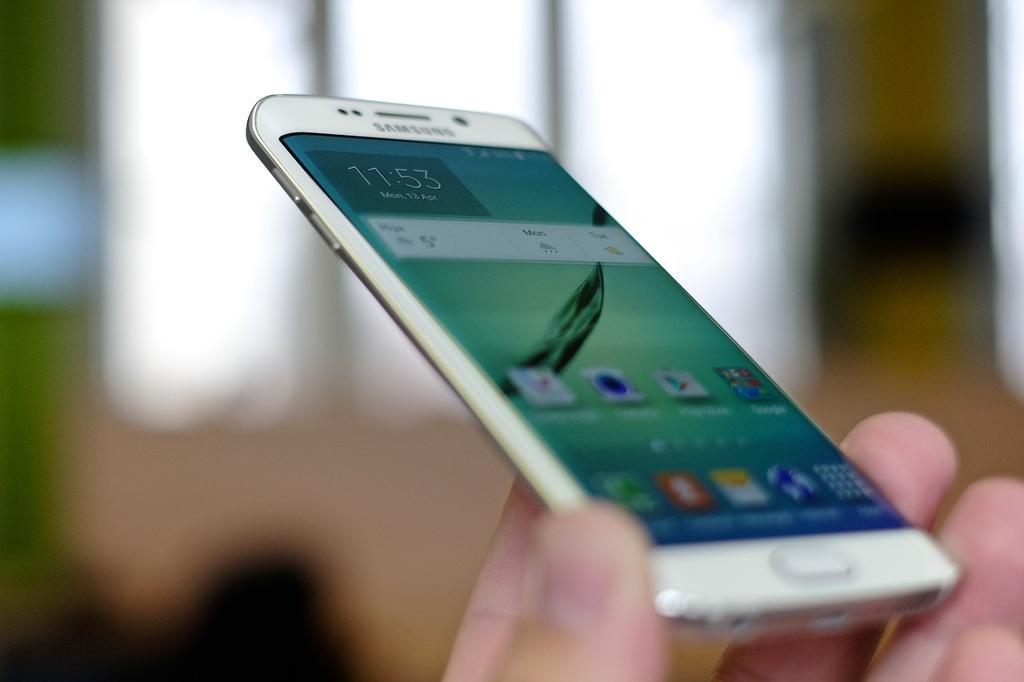Please provide a concise description of this image. In this picture, there is a hand holding a mobile. On the mobile screen, there are applications. 